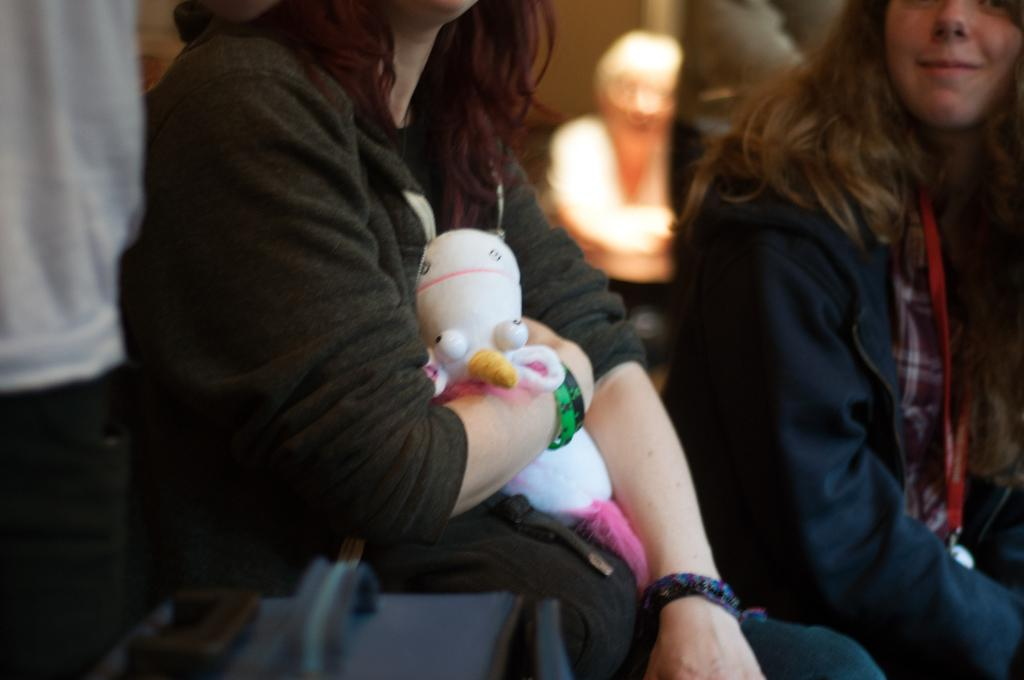How many people are sitting in the image? There are two people sitting in the image. What is one of the people holding? One person is holding a doll. Can you describe the person visible behind the sitting people? There is a person visible behind the sitting people, but no specific details are provided about this person. How many ladybugs are crawling on the letter in the image? There is no letter or ladybugs present in the image. 